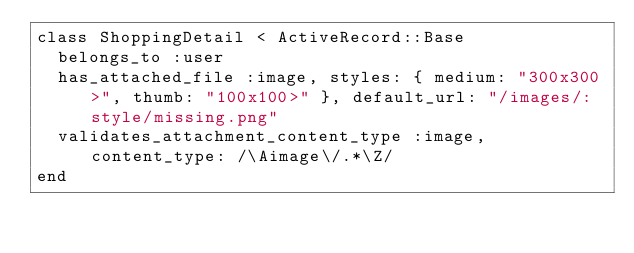<code> <loc_0><loc_0><loc_500><loc_500><_Ruby_>class ShoppingDetail < ActiveRecord::Base
  belongs_to :user
  has_attached_file :image, styles: { medium: "300x300>", thumb: "100x100>" }, default_url: "/images/:style/missing.png"
  validates_attachment_content_type :image, content_type: /\Aimage\/.*\Z/
end
</code> 